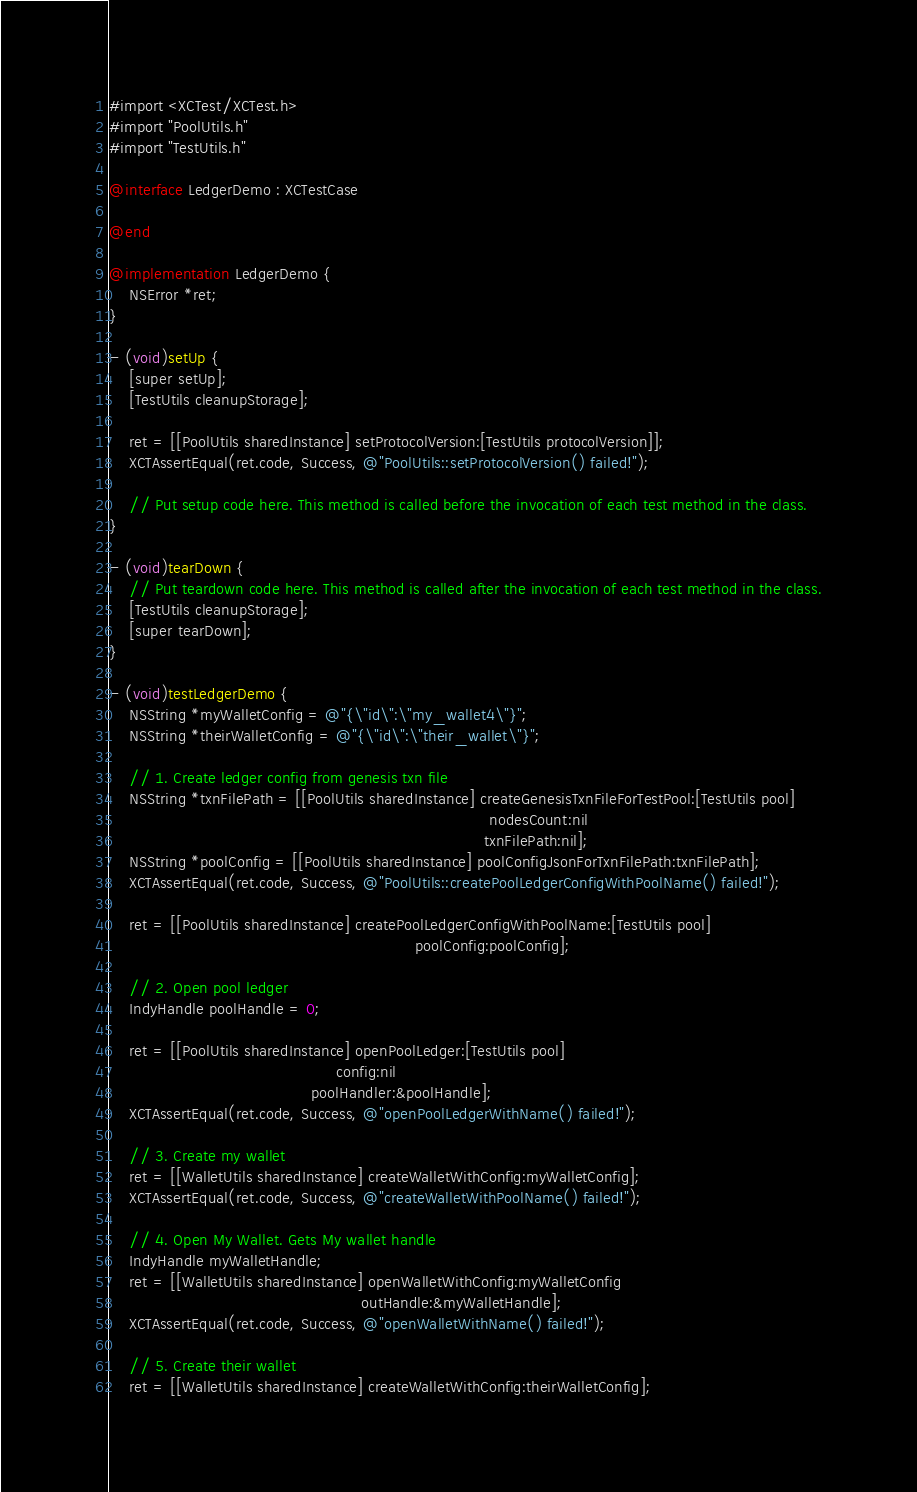Convert code to text. <code><loc_0><loc_0><loc_500><loc_500><_ObjectiveC_>#import <XCTest/XCTest.h>
#import "PoolUtils.h"
#import "TestUtils.h"

@interface LedgerDemo : XCTestCase

@end

@implementation LedgerDemo {
    NSError *ret;
}

- (void)setUp {
    [super setUp];
    [TestUtils cleanupStorage];

    ret = [[PoolUtils sharedInstance] setProtocolVersion:[TestUtils protocolVersion]];
    XCTAssertEqual(ret.code, Success, @"PoolUtils::setProtocolVersion() failed!");

    // Put setup code here. This method is called before the invocation of each test method in the class.
}

- (void)tearDown {
    // Put teardown code here. This method is called after the invocation of each test method in the class.
    [TestUtils cleanupStorage];
    [super tearDown];
}

- (void)testLedgerDemo {
    NSString *myWalletConfig = @"{\"id\":\"my_wallet4\"}";
    NSString *theirWalletConfig = @"{\"id\":\"their_wallet\"}";

    // 1. Create ledger config from genesis txn file
    NSString *txnFilePath = [[PoolUtils sharedInstance] createGenesisTxnFileForTestPool:[TestUtils pool]
                                                                             nodesCount:nil
                                                                            txnFilePath:nil];
    NSString *poolConfig = [[PoolUtils sharedInstance] poolConfigJsonForTxnFilePath:txnFilePath];
    XCTAssertEqual(ret.code, Success, @"PoolUtils::createPoolLedgerConfigWithPoolName() failed!");

    ret = [[PoolUtils sharedInstance] createPoolLedgerConfigWithPoolName:[TestUtils pool]
                                                              poolConfig:poolConfig];

    // 2. Open pool ledger
    IndyHandle poolHandle = 0;

    ret = [[PoolUtils sharedInstance] openPoolLedger:[TestUtils pool]
                                              config:nil
                                         poolHandler:&poolHandle];
    XCTAssertEqual(ret.code, Success, @"openPoolLedgerWithName() failed!");

    // 3. Create my wallet
    ret = [[WalletUtils sharedInstance] createWalletWithConfig:myWalletConfig];
    XCTAssertEqual(ret.code, Success, @"createWalletWithPoolName() failed!");

    // 4. Open My Wallet. Gets My wallet handle
    IndyHandle myWalletHandle;
    ret = [[WalletUtils sharedInstance] openWalletWithConfig:myWalletConfig
                                                   outHandle:&myWalletHandle];
    XCTAssertEqual(ret.code, Success, @"openWalletWithName() failed!");

    // 5. Create their wallet
    ret = [[WalletUtils sharedInstance] createWalletWithConfig:theirWalletConfig];</code> 